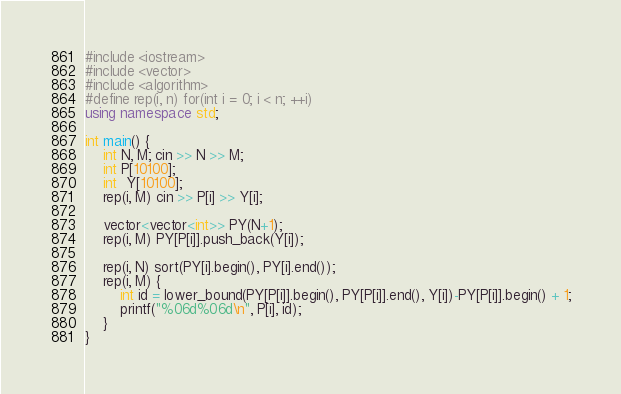<code> <loc_0><loc_0><loc_500><loc_500><_C++_>#include <iostream>
#include <vector>
#include <algorithm>
#define rep(i, n) for(int i = 0; i < n; ++i)
using namespace std;

int main() {
    int N, M; cin >> N >> M;
    int P[10100];
    int  Y[10100];
    rep(i, M) cin >> P[i] >> Y[i];

    vector<vector<int>> PY(N+1);
    rep(i, M) PY[P[i]].push_back(Y[i]);

    rep(i, N) sort(PY[i].begin(), PY[i].end());
    rep(i, M) {
        int id = lower_bound(PY[P[i]].begin(), PY[P[i]].end(), Y[i])-PY[P[i]].begin() + 1;
        printf("%06d%06d\n", P[i], id);
    }
}</code> 